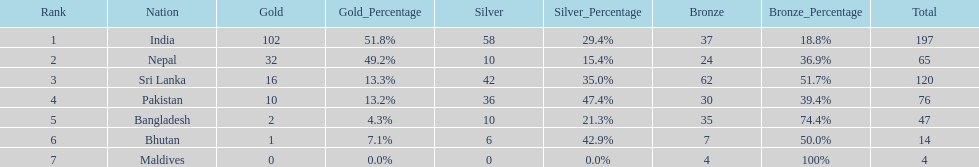What was the number of silver medals won by pakistan? 36. 